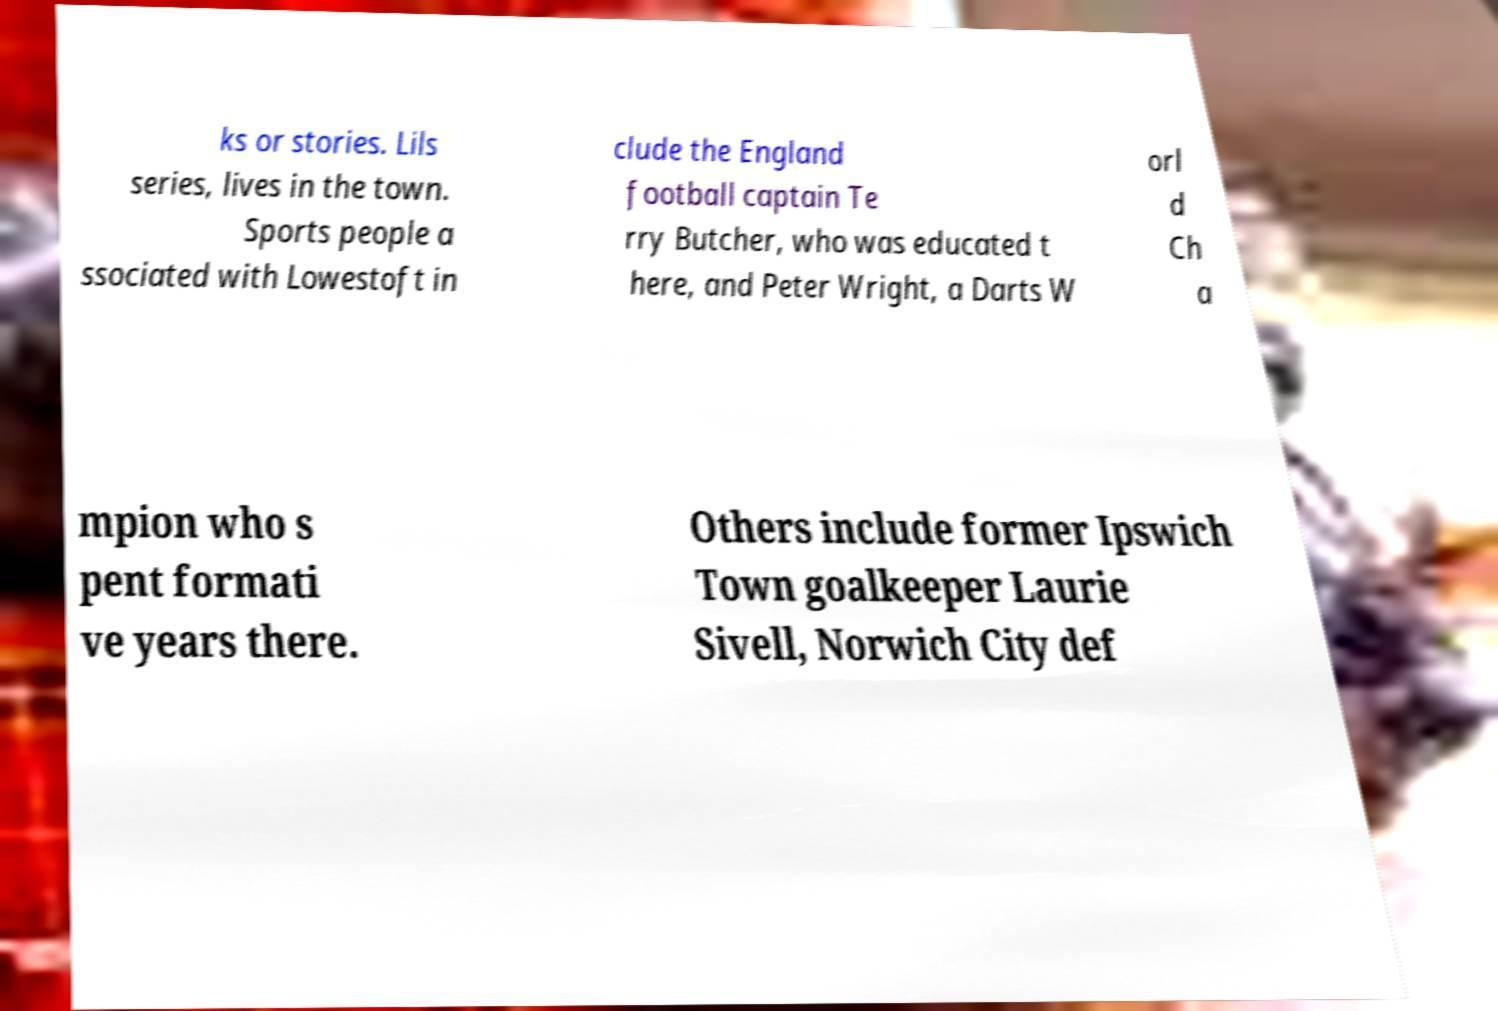Please identify and transcribe the text found in this image. ks or stories. Lils series, lives in the town. Sports people a ssociated with Lowestoft in clude the England football captain Te rry Butcher, who was educated t here, and Peter Wright, a Darts W orl d Ch a mpion who s pent formati ve years there. Others include former Ipswich Town goalkeeper Laurie Sivell, Norwich City def 